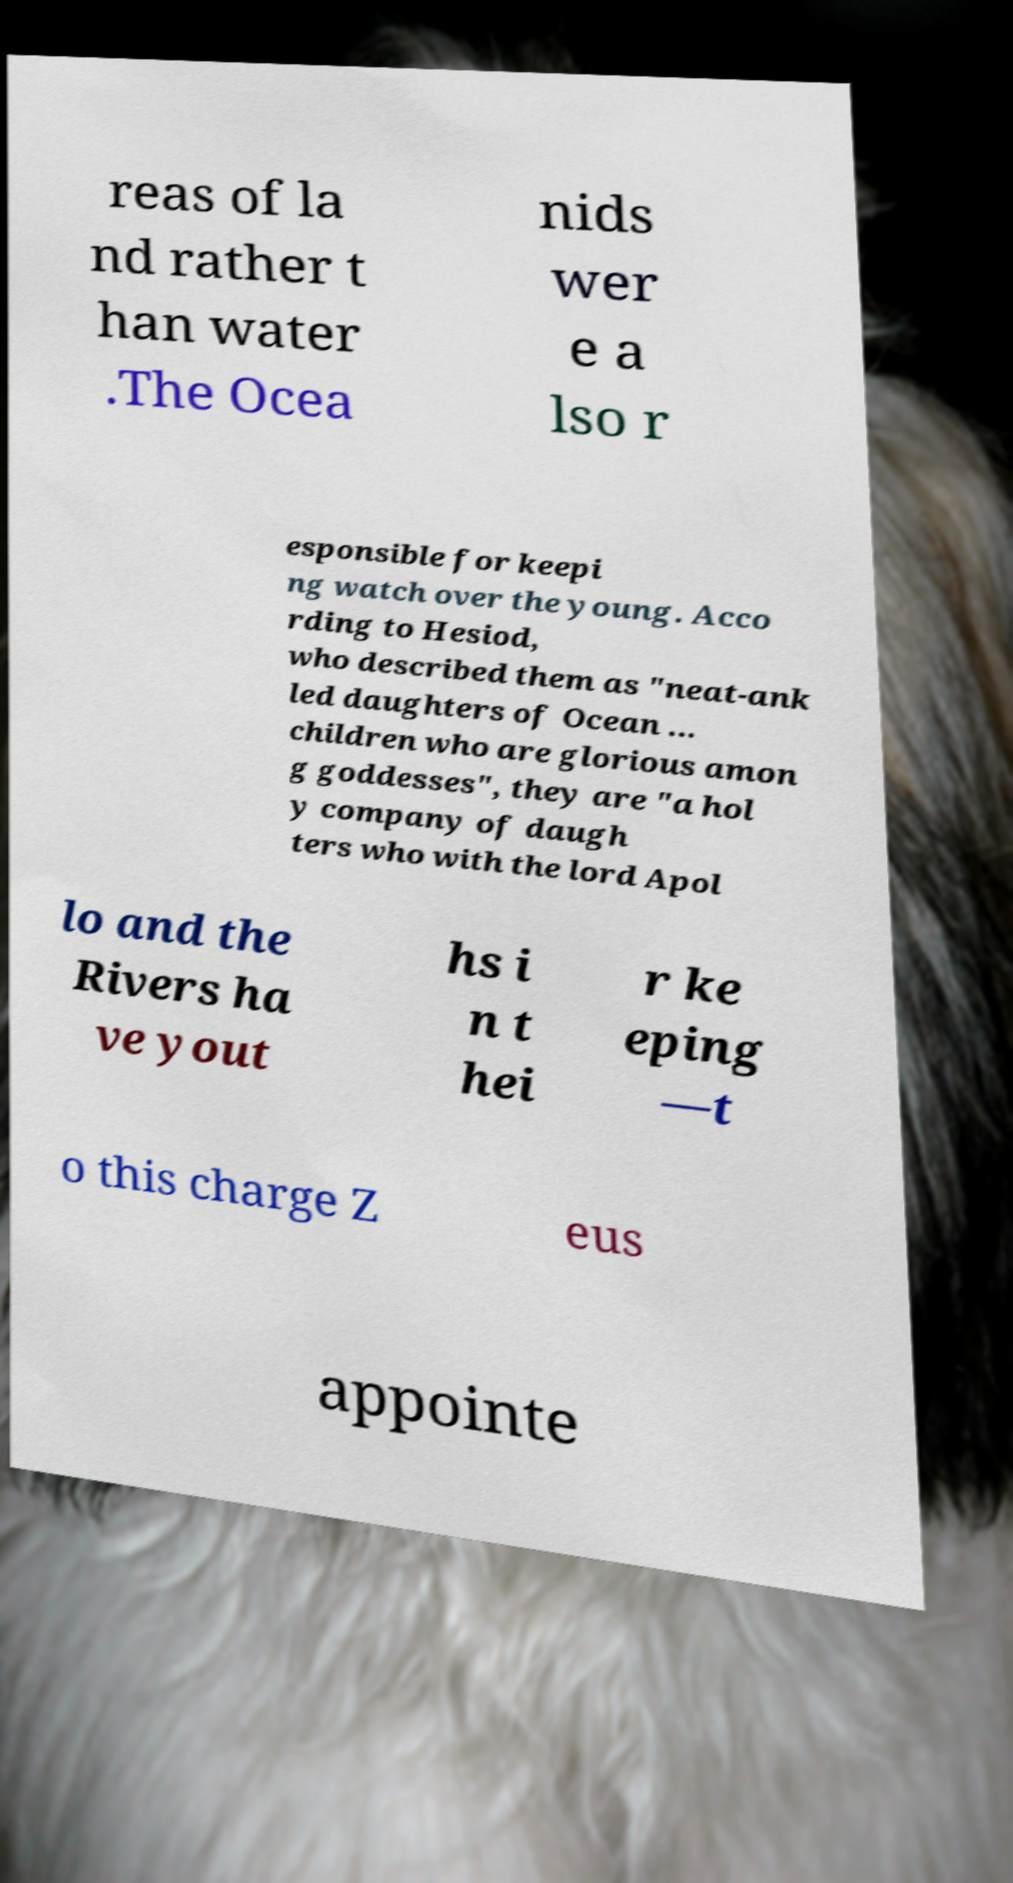I need the written content from this picture converted into text. Can you do that? reas of la nd rather t han water .The Ocea nids wer e a lso r esponsible for keepi ng watch over the young. Acco rding to Hesiod, who described them as "neat-ank led daughters of Ocean ... children who are glorious amon g goddesses", they are "a hol y company of daugh ters who with the lord Apol lo and the Rivers ha ve yout hs i n t hei r ke eping —t o this charge Z eus appointe 